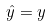Convert formula to latex. <formula><loc_0><loc_0><loc_500><loc_500>\hat { y } = y</formula> 